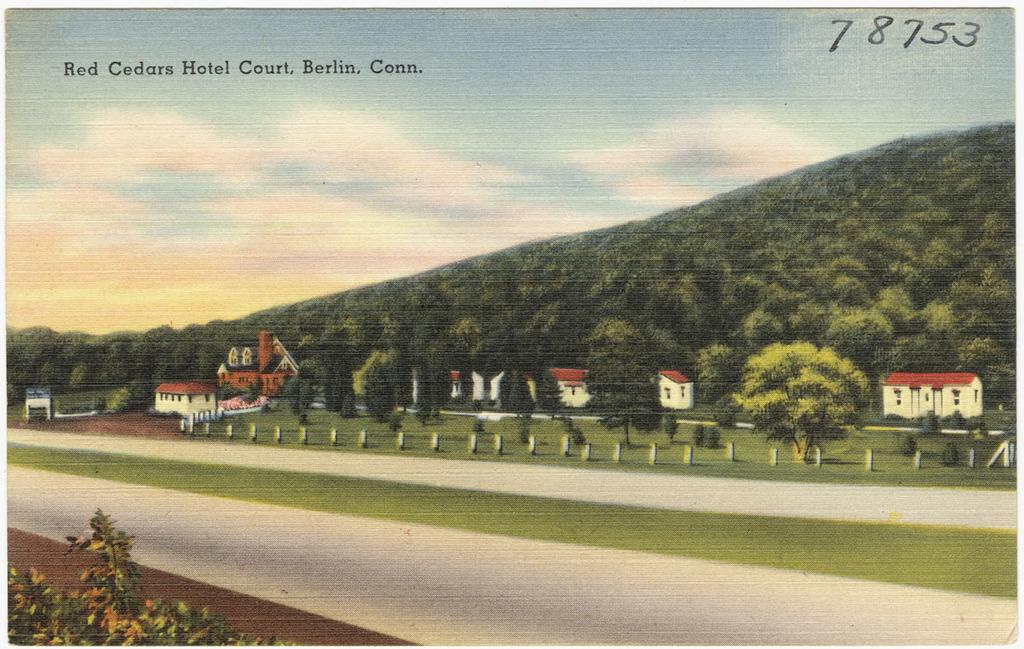What type of artwork is depicted in the image? The image appears to be a painting. What can be seen in the middle of the painting? There are trees and houses in the middle of the image. What is visible at the top of the painting? The sky is visible at the top of the image. What color is the text in the image? The text in the image is in black color. How many planes are flying in the sky in the image? There are no planes visible in the sky in the image. What type of waste is being disposed of in the painting? There is no waste present in the painting; it features trees, houses, and text. 